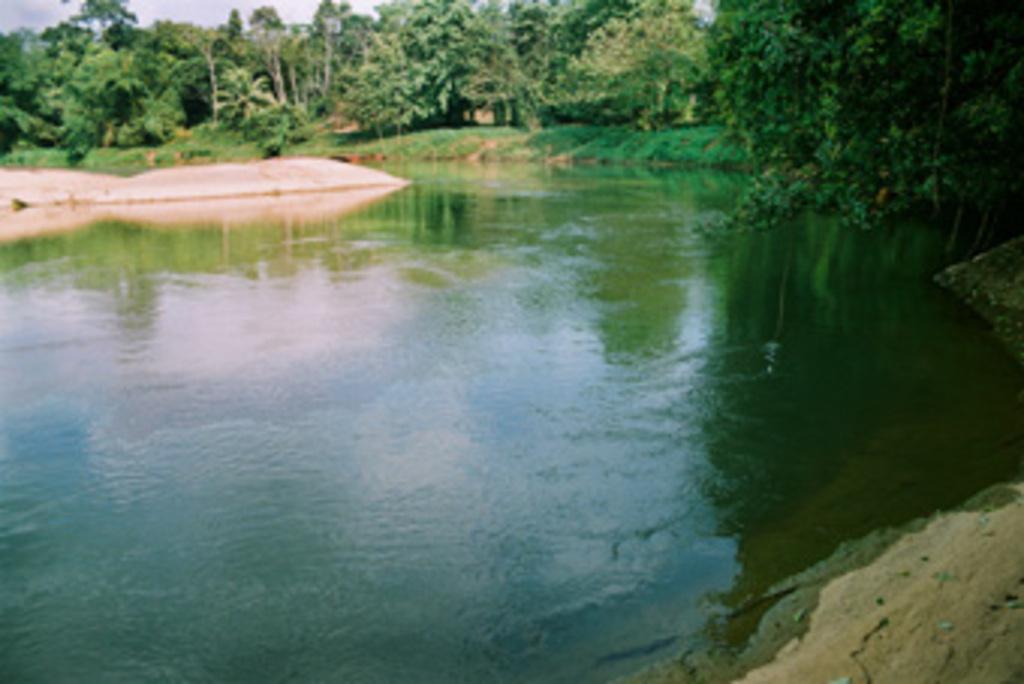Please provide a concise description of this image. In this picture we can see water at the bottom, in the background there are some trees, we can see grass where, there is the sky at the left top of the picture. 